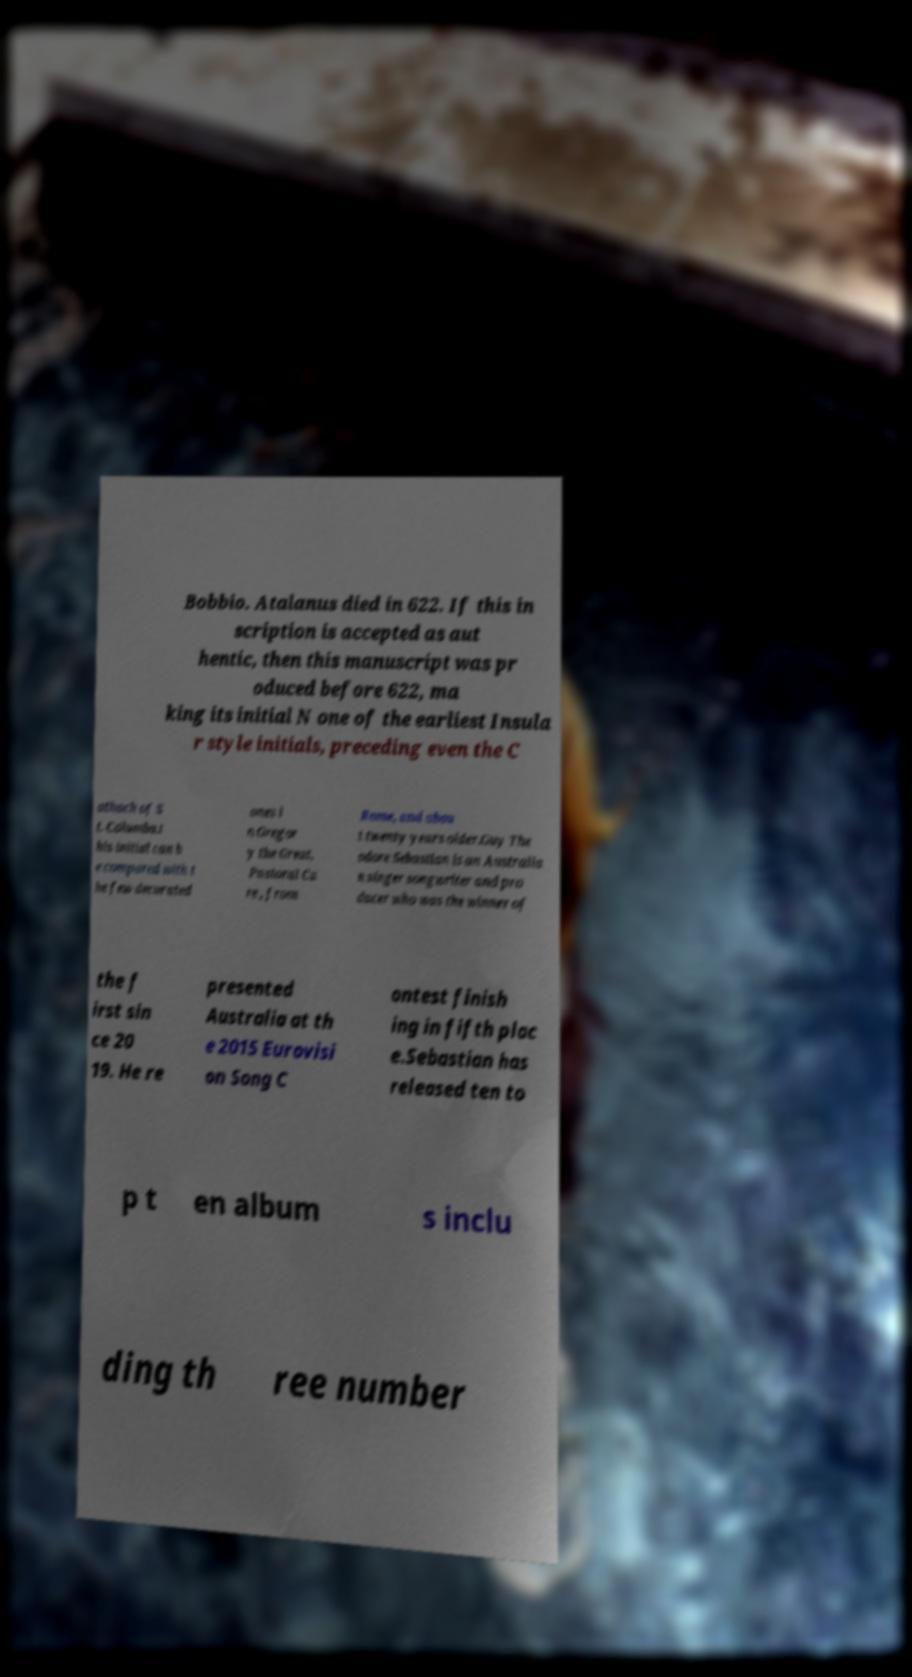For documentation purposes, I need the text within this image transcribed. Could you provide that? Bobbio. Atalanus died in 622. If this in scription is accepted as aut hentic, then this manuscript was pr oduced before 622, ma king its initial N one of the earliest Insula r style initials, preceding even the C athach of S t. Columba.t his initial can b e compared with t he few decorated ones i n Gregor y the Great, Pastoral Ca re , from Rome, and abou t twenty years older.Guy The odore Sebastian is an Australia n singer songwriter and pro ducer who was the winner of the f irst sin ce 20 19. He re presented Australia at th e 2015 Eurovisi on Song C ontest finish ing in fifth plac e.Sebastian has released ten to p t en album s inclu ding th ree number 